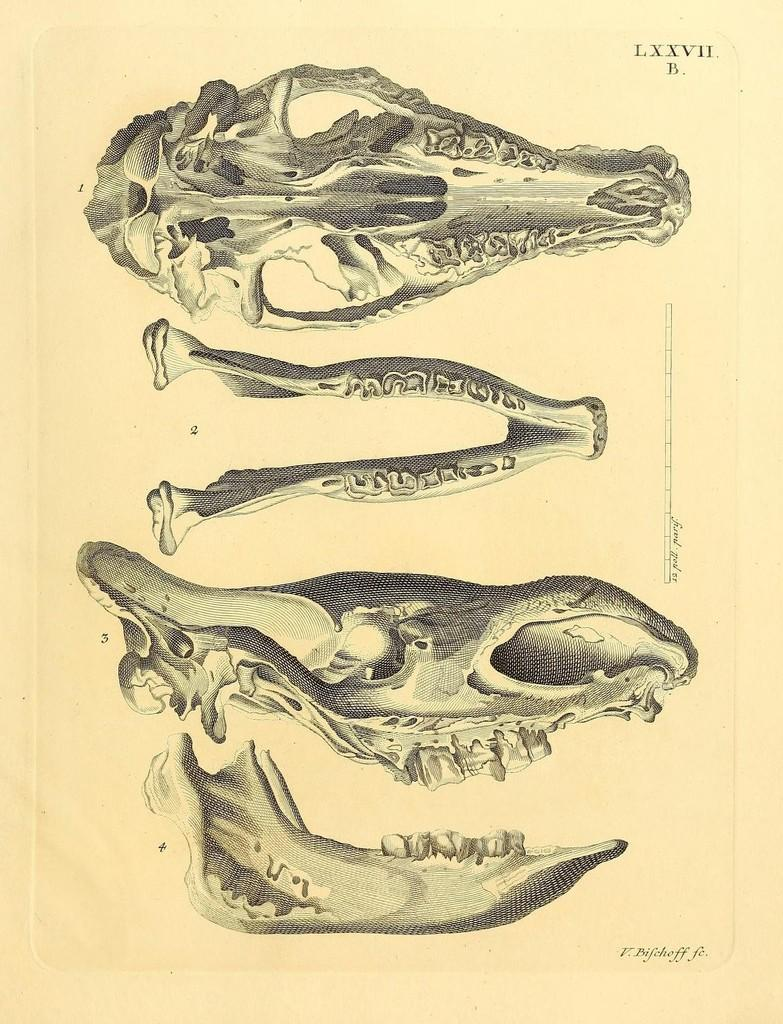What type of image is being described? The image is a drawing. What can be seen in the drawing? There are skulls in the drawing. What type of holiday is being celebrated in the drawing? There is no indication of a holiday being celebrated in the drawing, as it only features skulls. How many clovers can be seen in the drawing? There are no clovers present in the drawing; it only features skulls. 